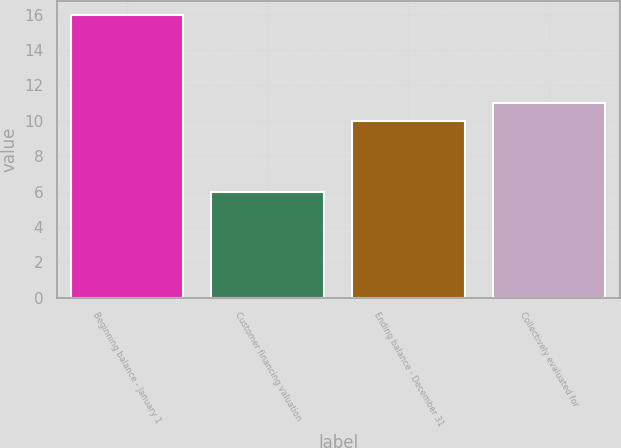Convert chart. <chart><loc_0><loc_0><loc_500><loc_500><bar_chart><fcel>Beginning balance - January 1<fcel>Customer financing valuation<fcel>Ending balance - December 31<fcel>Collectively evaluated for<nl><fcel>16<fcel>6<fcel>10<fcel>11<nl></chart> 